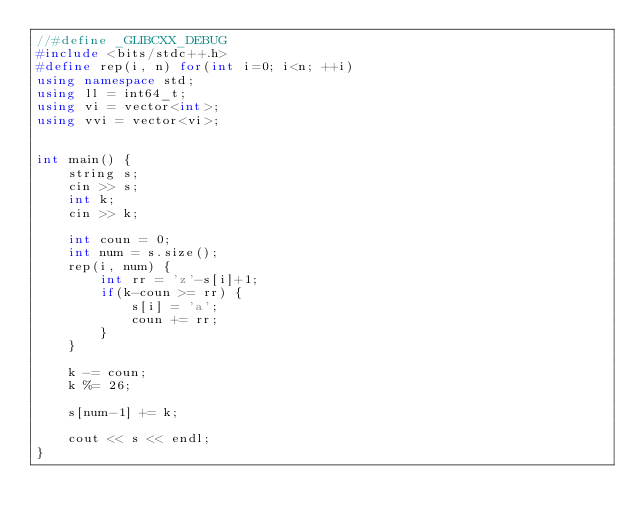Convert code to text. <code><loc_0><loc_0><loc_500><loc_500><_C++_>//#define _GLIBCXX_DEBUG
#include <bits/stdc++.h>
#define rep(i, n) for(int i=0; i<n; ++i)
using namespace std;
using ll = int64_t;
using vi = vector<int>;
using vvi = vector<vi>;


int main() {
    string s;
    cin >> s;
    int k;
    cin >> k;

    int coun = 0;
    int num = s.size();
    rep(i, num) {
        int rr = 'z'-s[i]+1;
        if(k-coun >= rr) {
            s[i] = 'a';
            coun += rr;
        }
    }

    k -= coun;
    k %= 26;

    s[num-1] += k;

    cout << s << endl;
}</code> 